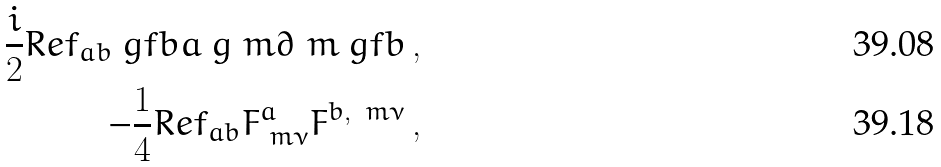Convert formula to latex. <formula><loc_0><loc_0><loc_500><loc_500>\frac { i } { 2 } R e f _ { a b } \ g f b a \ g ^ { \ } m \partial _ { \ } m \ g f b \, , \\ - \frac { 1 } { 4 } R e f _ { a b } F _ { \ m \nu } ^ { a } F ^ { b , \, \ m \nu } \, ,</formula> 